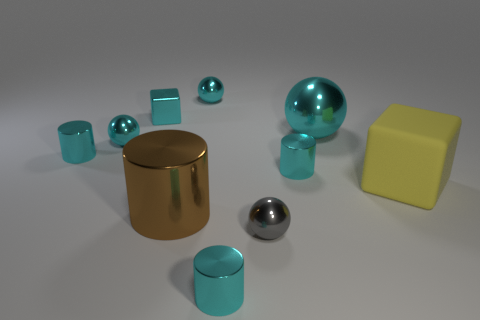How many cyan spheres must be subtracted to get 1 cyan spheres? 2 Subtract all green balls. How many cyan cylinders are left? 3 Subtract all cylinders. How many objects are left? 6 Add 4 big cyan spheres. How many big cyan spheres are left? 5 Add 1 tiny gray matte spheres. How many tiny gray matte spheres exist? 1 Subtract 0 purple cylinders. How many objects are left? 10 Subtract all tiny yellow matte blocks. Subtract all large metallic cylinders. How many objects are left? 9 